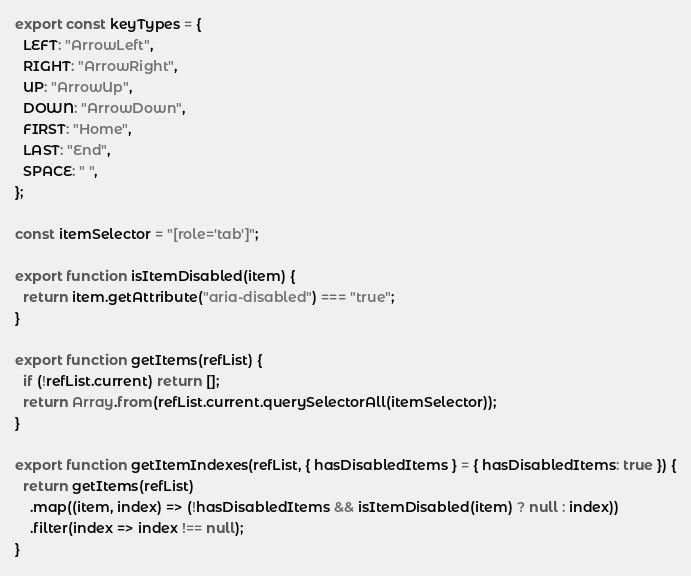<code> <loc_0><loc_0><loc_500><loc_500><_JavaScript_>export const keyTypes = {
  LEFT: "ArrowLeft",
  RIGHT: "ArrowRight",
  UP: "ArrowUp",
  DOWN: "ArrowDown",
  FIRST: "Home",
  LAST: "End",
  SPACE: " ",
};

const itemSelector = "[role='tab']";

export function isItemDisabled(item) {
  return item.getAttribute("aria-disabled") === "true";
}

export function getItems(refList) {
  if (!refList.current) return [];
  return Array.from(refList.current.querySelectorAll(itemSelector));
}

export function getItemIndexes(refList, { hasDisabledItems } = { hasDisabledItems: true }) {
  return getItems(refList)
    .map((item, index) => (!hasDisabledItems && isItemDisabled(item) ? null : index))
    .filter(index => index !== null);
}
</code> 